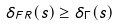Convert formula to latex. <formula><loc_0><loc_0><loc_500><loc_500>\delta _ { F R } ( s ) \geq \delta _ { \Gamma } ( s )</formula> 